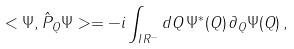Convert formula to latex. <formula><loc_0><loc_0><loc_500><loc_500>< \Psi , \hat { P } _ { Q } \Psi > = - i \int _ { I \, R ^ { - } } d Q \, \Psi ^ { \ast } ( Q ) \, \partial _ { Q } \Psi ( Q ) \, ,</formula> 